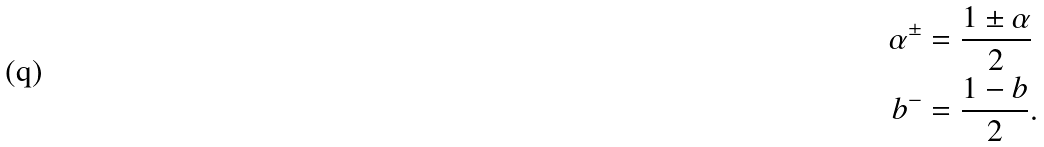Convert formula to latex. <formula><loc_0><loc_0><loc_500><loc_500>\alpha ^ { \pm } & = \frac { 1 \pm \alpha } { 2 } \\ b ^ { - } & = \frac { 1 - b } { 2 } .</formula> 